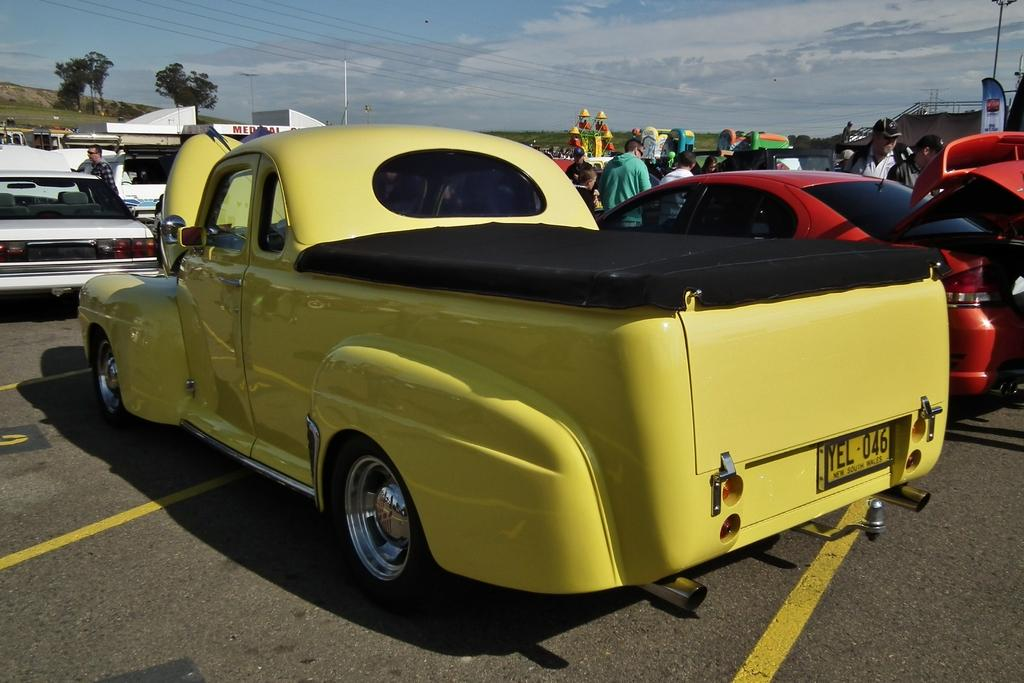What type of vehicles can be seen in the image? There are cars in the image. What are the people in the image doing? The people are standing on the road in the image. What type of vegetation is present in the image? There are trees and grass in the image. What additional object can be seen in the image? There is a banner in the image. What structures are present in the image? There are poles in the image. What else can be seen in the image? There are wires and some objects in the image. What is visible in the background of the image? The sky is visible in the background of the image, and there are clouds in the sky. How many apples are hanging from the wires in the image? There are no apples present in the image; only cars, people, trees, grass, a banner, poles, wires, and objects can be seen. What type of pest is crawling on the banner in the image? There are no pests visible on the banner or anywhere else in the image. What is the person carrying in the sack in the image? There is no person carrying a sack in the image. 